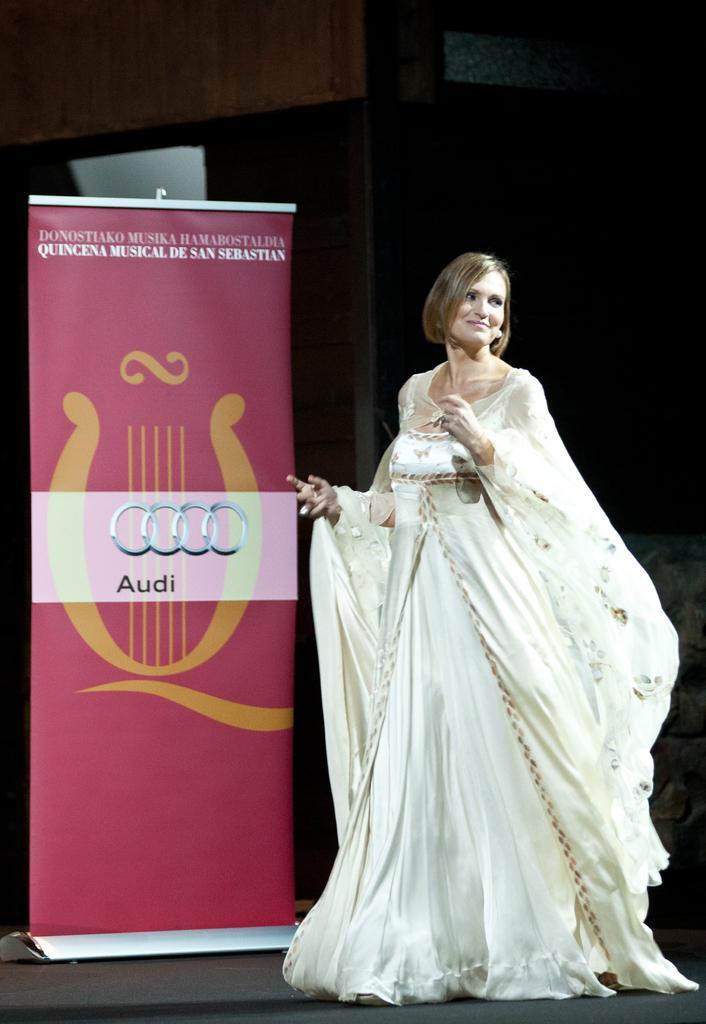How would you summarize this image in a sentence or two? In the picture I can see a woman wearing a white color dress is standing on the right side of the image and smiling. On the left side of the image we can a banner on which we can see a logo and some text and the background of the image is dark. 